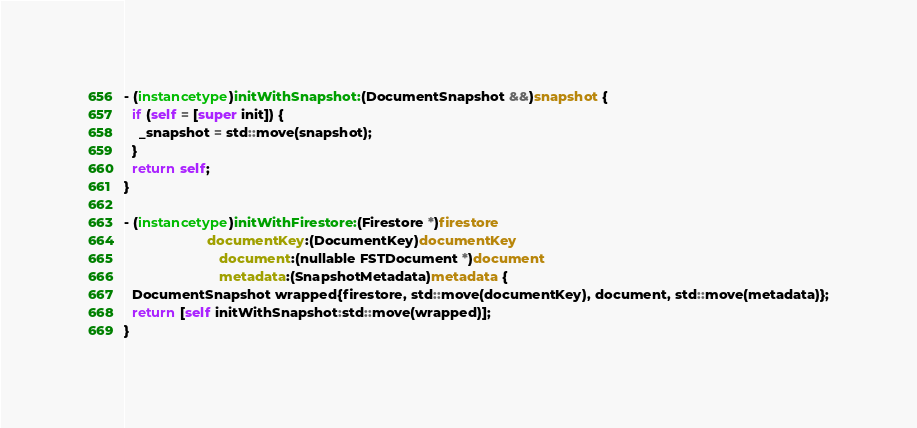<code> <loc_0><loc_0><loc_500><loc_500><_ObjectiveC_>
- (instancetype)initWithSnapshot:(DocumentSnapshot &&)snapshot {
  if (self = [super init]) {
    _snapshot = std::move(snapshot);
  }
  return self;
}

- (instancetype)initWithFirestore:(Firestore *)firestore
                      documentKey:(DocumentKey)documentKey
                         document:(nullable FSTDocument *)document
                         metadata:(SnapshotMetadata)metadata {
  DocumentSnapshot wrapped{firestore, std::move(documentKey), document, std::move(metadata)};
  return [self initWithSnapshot:std::move(wrapped)];
}
</code> 